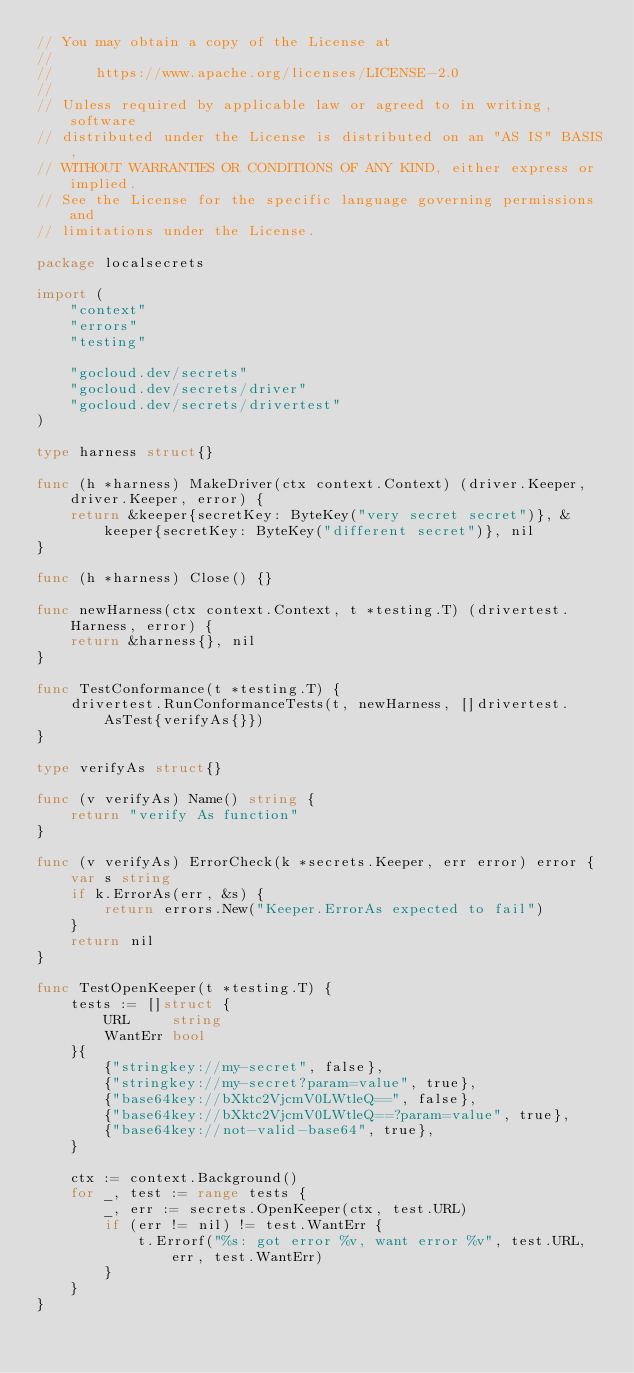Convert code to text. <code><loc_0><loc_0><loc_500><loc_500><_Go_>// You may obtain a copy of the License at
//
//     https://www.apache.org/licenses/LICENSE-2.0
//
// Unless required by applicable law or agreed to in writing, software
// distributed under the License is distributed on an "AS IS" BASIS,
// WITHOUT WARRANTIES OR CONDITIONS OF ANY KIND, either express or implied.
// See the License for the specific language governing permissions and
// limitations under the License.

package localsecrets

import (
	"context"
	"errors"
	"testing"

	"gocloud.dev/secrets"
	"gocloud.dev/secrets/driver"
	"gocloud.dev/secrets/drivertest"
)

type harness struct{}

func (h *harness) MakeDriver(ctx context.Context) (driver.Keeper, driver.Keeper, error) {
	return &keeper{secretKey: ByteKey("very secret secret")}, &keeper{secretKey: ByteKey("different secret")}, nil
}

func (h *harness) Close() {}

func newHarness(ctx context.Context, t *testing.T) (drivertest.Harness, error) {
	return &harness{}, nil
}

func TestConformance(t *testing.T) {
	drivertest.RunConformanceTests(t, newHarness, []drivertest.AsTest{verifyAs{}})
}

type verifyAs struct{}

func (v verifyAs) Name() string {
	return "verify As function"
}

func (v verifyAs) ErrorCheck(k *secrets.Keeper, err error) error {
	var s string
	if k.ErrorAs(err, &s) {
		return errors.New("Keeper.ErrorAs expected to fail")
	}
	return nil
}

func TestOpenKeeper(t *testing.T) {
	tests := []struct {
		URL     string
		WantErr bool
	}{
		{"stringkey://my-secret", false},
		{"stringkey://my-secret?param=value", true},
		{"base64key://bXktc2VjcmV0LWtleQ==", false},
		{"base64key://bXktc2VjcmV0LWtleQ==?param=value", true},
		{"base64key://not-valid-base64", true},
	}

	ctx := context.Background()
	for _, test := range tests {
		_, err := secrets.OpenKeeper(ctx, test.URL)
		if (err != nil) != test.WantErr {
			t.Errorf("%s: got error %v, want error %v", test.URL, err, test.WantErr)
		}
	}
}
</code> 